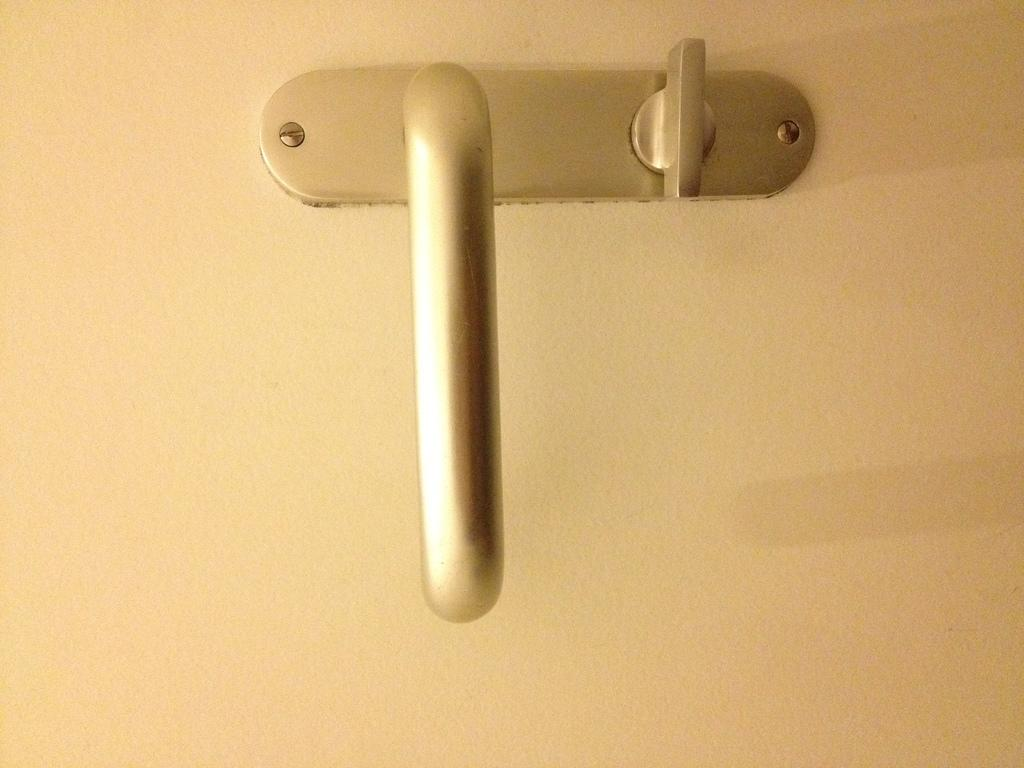What is the main object in the center of the image? There is a handle on a door in the center of the image. Where is the sofa located in the image? There is no sofa present in the image. What type of agreement is being made in the image? There is no agreement being made in the image; it only features a handle on a door. 